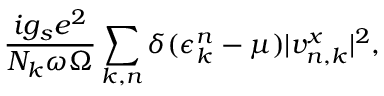Convert formula to latex. <formula><loc_0><loc_0><loc_500><loc_500>\frac { i g _ { s } e ^ { 2 } } { N _ { k } \omega \Omega } \sum _ { k , n } \delta ( \epsilon _ { k } ^ { n } - \mu ) | v _ { n , k } ^ { x } | ^ { 2 } ,</formula> 